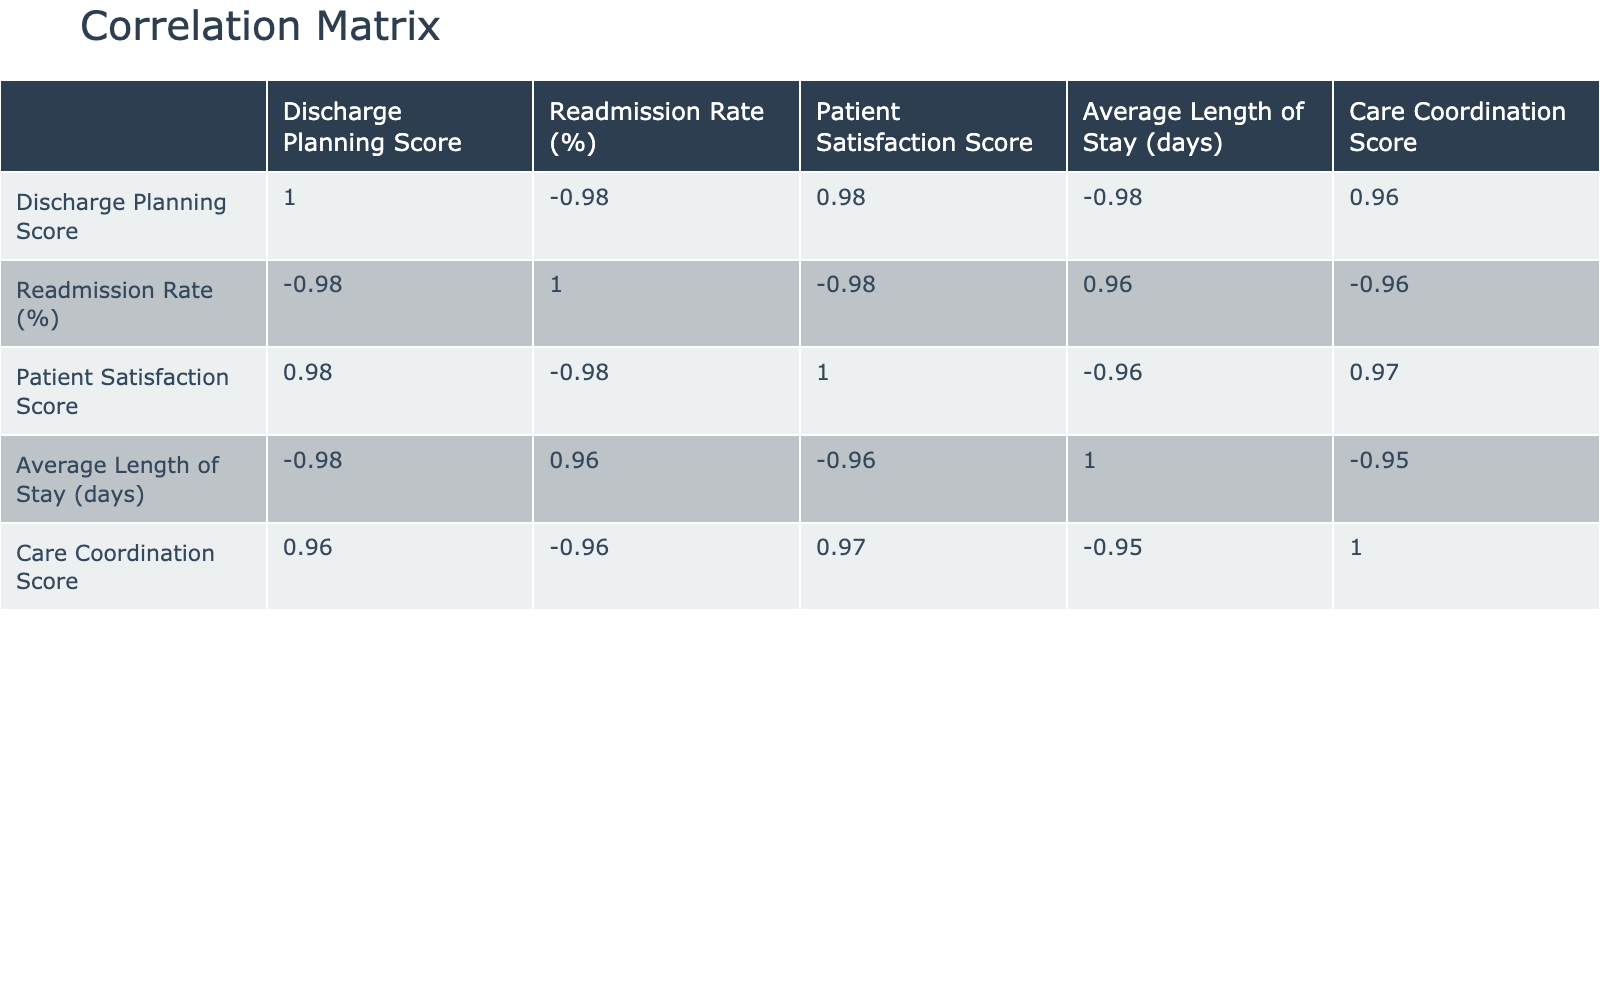What is the discharge planning score of Hilltop Community Hospital? According to the table, Hilltop Community Hospital has a discharge planning score of 92, which can be found in the corresponding row.
Answer: 92 What is the readmission rate percentage for City General Hospital? The readmission rate for City General Hospital is 12.5%, which is listed in the readmission rate column for that hospital.
Answer: 12.5% Is the care coordination score higher for Lakeside Medical Center than for Oakwood Regional Medical Center? Lakeside Medical Center has a care coordination score of 80, while Oakwood Regional Medical Center has a score of 82. Therefore, it is false that Lakeside Medical Center scores higher.
Answer: No What is the average readmission rate across all hospitals listed? The readmission rates are 12.5, 15.0, 8.0, 20.0, 14.0, 11.0, 18.0, and 9.0. Summing these values gives 108.5, and dividing by 8 (the number of hospitals) results in an average of 13.56.
Answer: 13.56 Which hospital has the lowest average length of stay? By examining the average length of stay column, we find that Springfield Teaching Hospital has the lowest average length of stay at 3.5 days.
Answer: Springfield Teaching Hospital Does a higher discharge planning score correlate with a lower readmission rate based on the data provided? Observing the correlation values in the table, we find a negative correlation between discharge planning score and readmission rate, indicating that as the discharge planning score increases, the readmission rate tends to decrease. Therefore, the answer is yes.
Answer: Yes What is the difference in readmission rates between Riverbend Health and Hilltop Community Hospital? Riverbend Health has a readmission rate of 20.0%, while Hilltop Community Hospital has a readmission rate of 8.0%. The difference is calculated as 20.0 - 8.0 = 12.0%.
Answer: 12.0% Which hospital has the highest patient satisfaction score? Looking at the patient satisfaction score column, Hilltop Community Hospital has the highest score at 92%.
Answer: Hilltop Community Hospital What percentage of hospitals have a readmission rate greater than 15%? The hospitals with readmission rates greater than 15% are Lakeside Medical Center, Riverbend Health, and Mountain Ridge Medical Center—three hospitals out of a total of eight, which means 3/8 equals 37.5%.
Answer: 37.5% 